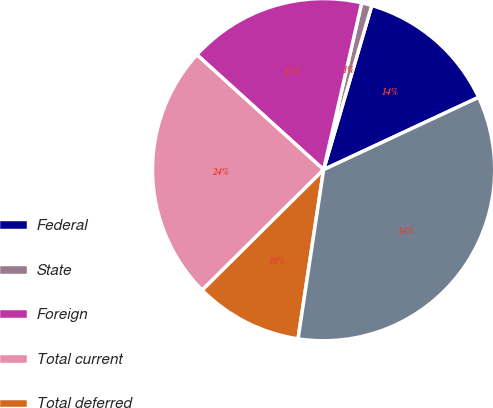Convert chart. <chart><loc_0><loc_0><loc_500><loc_500><pie_chart><fcel>Federal<fcel>State<fcel>Foreign<fcel>Total current<fcel>Total deferred<fcel>Total provision for income<nl><fcel>13.51%<fcel>0.97%<fcel>16.85%<fcel>24.17%<fcel>10.17%<fcel>34.34%<nl></chart> 